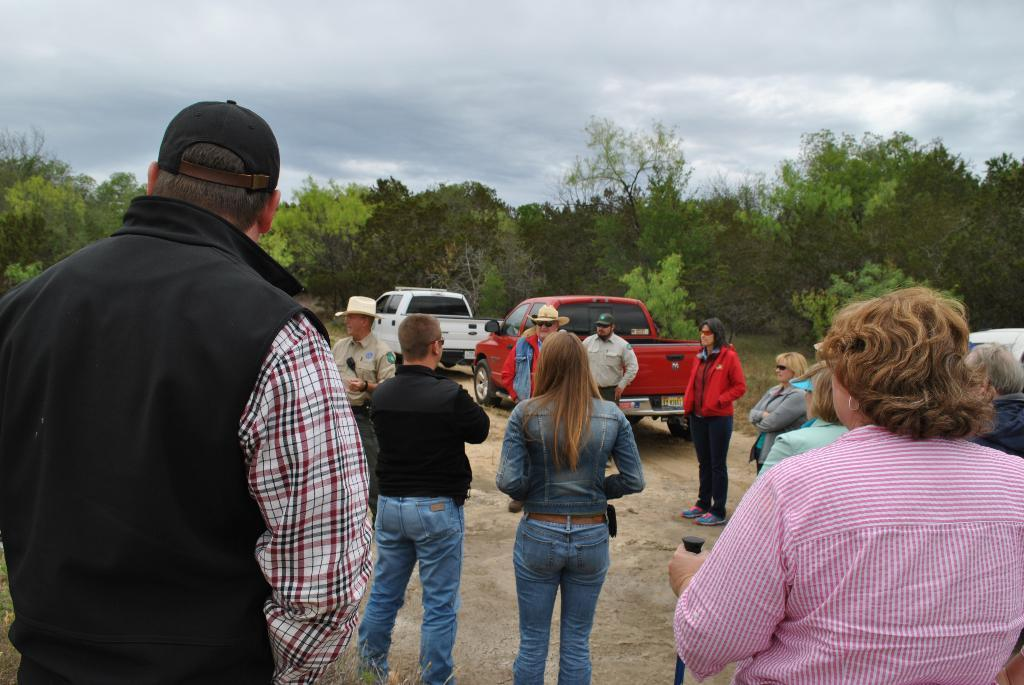What are the people in the image doing? The people in the image are standing on the ground. What vehicles can be seen in the image? There are two trucks on a pathway in the image. What type of vegetation is visible in the background of the image? There is a group of trees visible in the background of the image. How would you describe the sky in the image? The sky is visible in the image and appears cloudy. What type of news can be heard coming from the trucks in the image? There is no indication in the image that the trucks are broadcasting any news, so it's not possible to determine what, if any, news might be heard. 